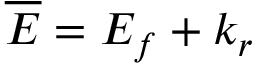<formula> <loc_0><loc_0><loc_500><loc_500>{ \overline { E } } = E _ { f } + k _ { r }</formula> 